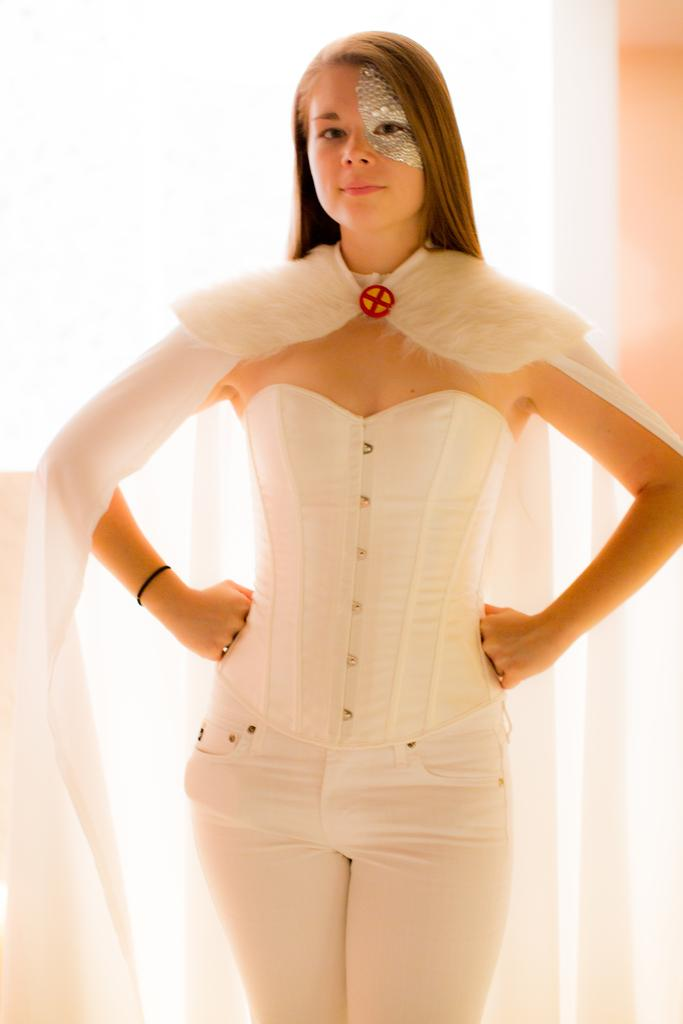What is present in the image? There is a person in the image. What is notable about the person's appearance? The person is wearing a costume. What type of yarn is being used to decorate the flowers in the image? There are no flowers or yarn present in the image; it features a person wearing a costume. 